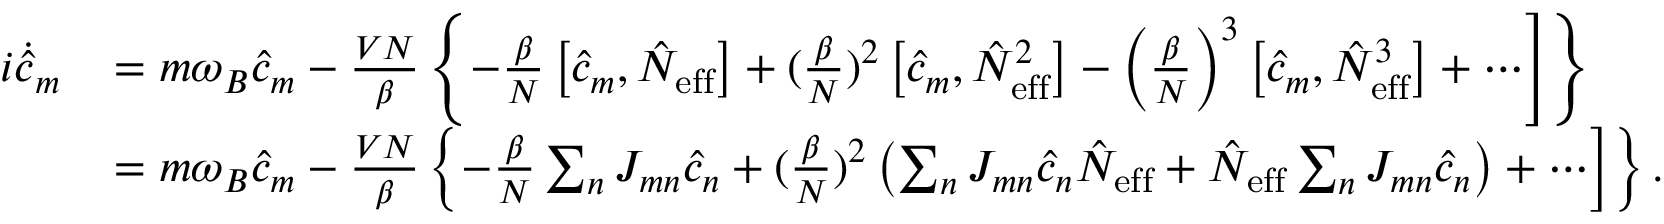Convert formula to latex. <formula><loc_0><loc_0><loc_500><loc_500>\begin{array} { r l } { i \dot { \hat { c } } _ { m } } & { = m \omega _ { B } \hat { c } _ { m } - \frac { V N } { \beta } \left \{ - \frac { \beta } { N } \left [ \hat { c } _ { m } , \hat { N } _ { e f f } \right ] + ( \frac { \beta } { N } ) ^ { 2 } \left [ \hat { c } _ { m } , \hat { N } _ { e f f } ^ { 2 } \right ] - \left ( \frac { \beta } { N } \right ) ^ { 3 } \left [ \hat { c } _ { m } , \hat { N } _ { e f f } ^ { 3 } \right ] + \cdots \right ] \right \} } \\ & { = m \omega _ { B } \hat { c } _ { m } - \frac { V N } { \beta } \left \{ - \frac { \beta } { N } \sum _ { n } J _ { m n } \hat { c } _ { n } + ( \frac { \beta } { N } ) ^ { 2 } \left ( \sum _ { n } J _ { m n } \hat { c } _ { n } \hat { N } _ { e f f } + \hat { N } _ { e f f } \sum _ { n } J _ { m n } \hat { c } _ { n } \right ) + \cdots \right ] \right \} . } \end{array}</formula> 